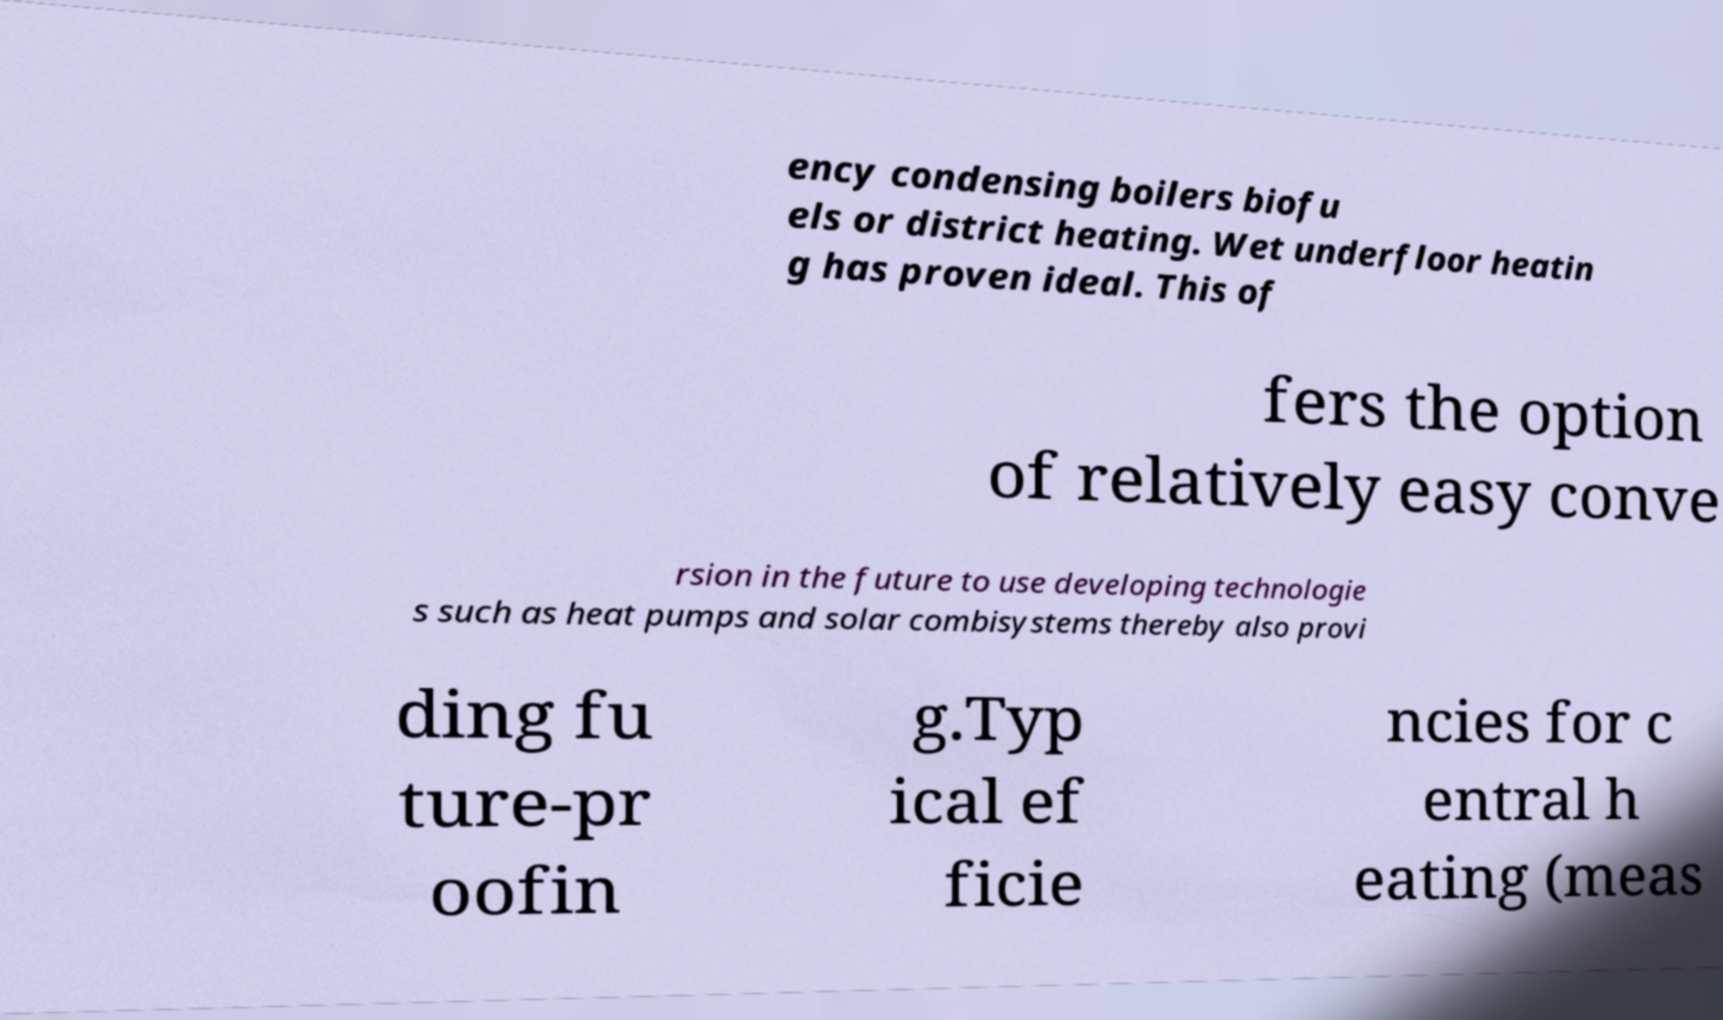Could you assist in decoding the text presented in this image and type it out clearly? ency condensing boilers biofu els or district heating. Wet underfloor heatin g has proven ideal. This of fers the option of relatively easy conve rsion in the future to use developing technologie s such as heat pumps and solar combisystems thereby also provi ding fu ture-pr oofin g.Typ ical ef ficie ncies for c entral h eating (meas 